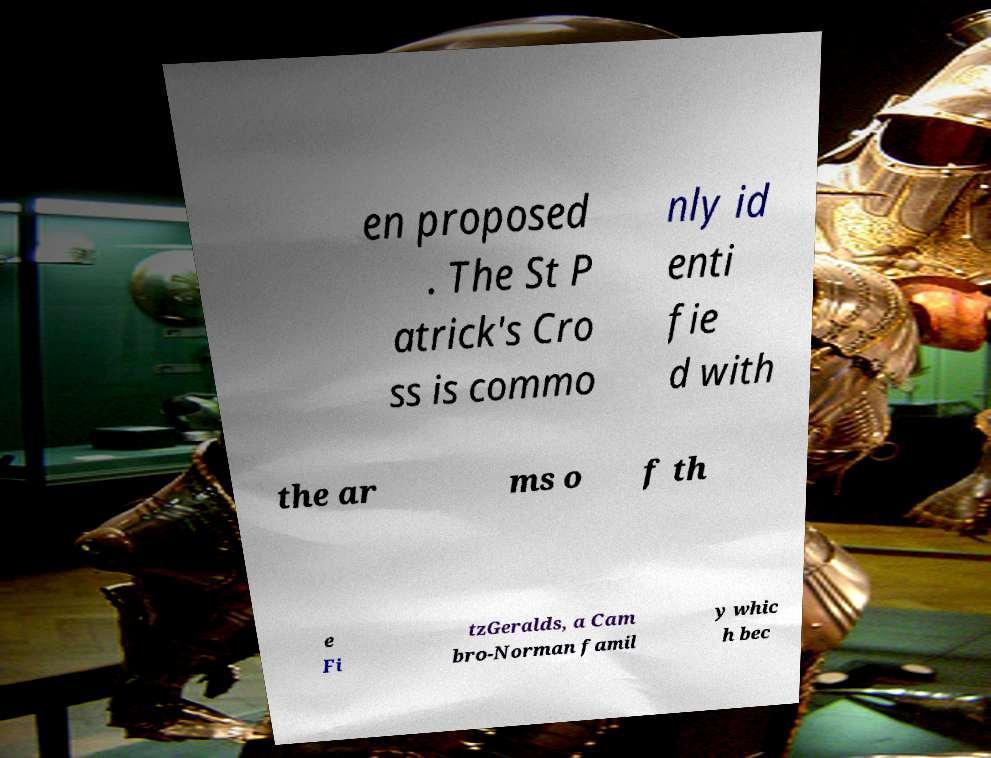Please read and relay the text visible in this image. What does it say? en proposed . The St P atrick's Cro ss is commo nly id enti fie d with the ar ms o f th e Fi tzGeralds, a Cam bro-Norman famil y whic h bec 